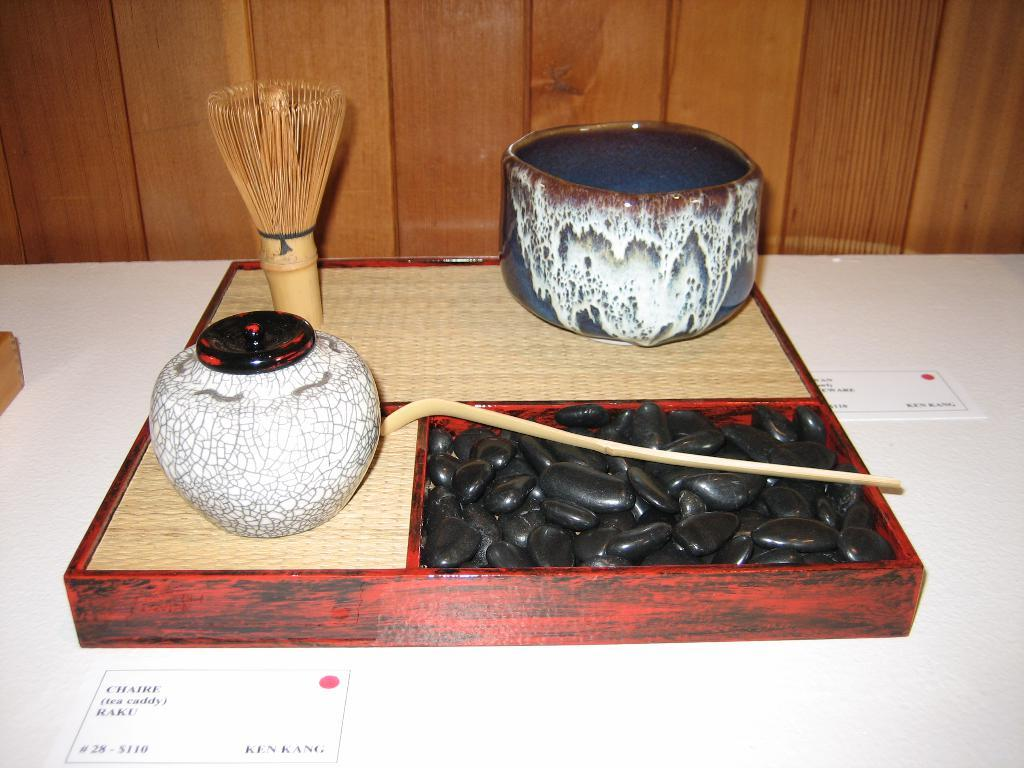What is located in the middle of the image? The wooden box is in the middle of the image. What is the wooden box containing? There are objects in a wooden box in the image. What is the color of the floor in the image? The wooden box is on a white color floor. What can be seen in the background of the image? There is a wooden wall in the background of the image. Can you see any seashore in the image? There is no seashore present in the image; it features a wooden box with objects on a white floor and a wooden wall in the background. 